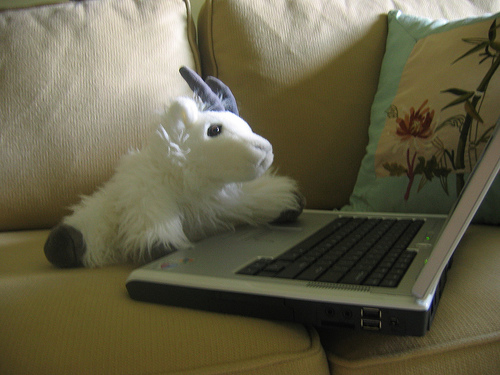<image>
Is there a goat on the laptop? Yes. Looking at the image, I can see the goat is positioned on top of the laptop, with the laptop providing support. 